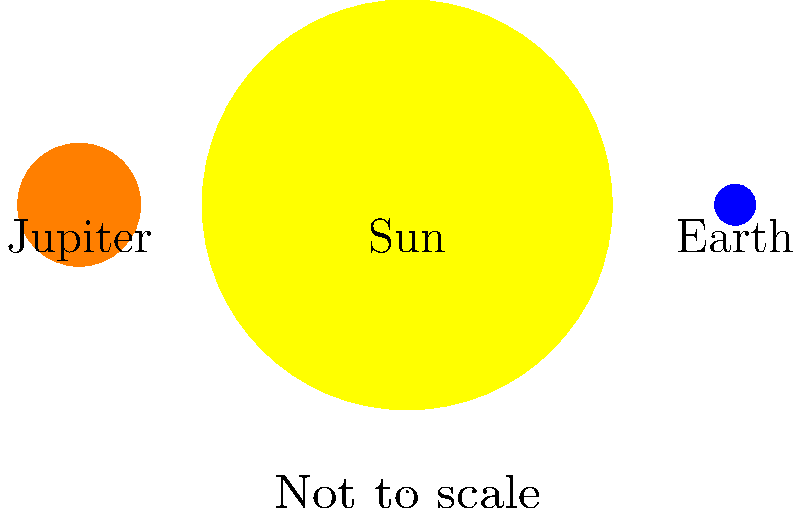In this movie-inspired space scene, we see the Sun, Earth, and Jupiter. If the Sun's circle represents its actual size, about how many Earths could fit inside the Sun based on their relative sizes shown here? Let's approach this step-by-step:

1. First, we need to compare the radii of the Sun and Earth in the image:
   Sun's radius = 5 units
   Earth's radius = 0.5 units

2. To find how many Earths can fit inside the Sun, we need to compare their volumes. The volume of a sphere is proportional to the cube of its radius.

3. Let's calculate the ratio of their volumes:
   $\frac{Volume_{Sun}}{Volume_{Earth}} = \frac{(Radius_{Sun})^3}{(Radius_{Earth})^3}$

4. Plugging in the values:
   $\frac{Volume_{Sun}}{Volume_{Earth}} = \frac{5^3}{0.5^3} = \frac{125}{0.125} = 1000$

5. This means that based on the sizes shown in the image, about 1000 Earths could fit inside the Sun.

6. In reality, about 1.3 million Earths can fit inside the Sun, but this simplified model gives us a good idea of how much larger the Sun is compared to Earth.
Answer: 1000 Earths 